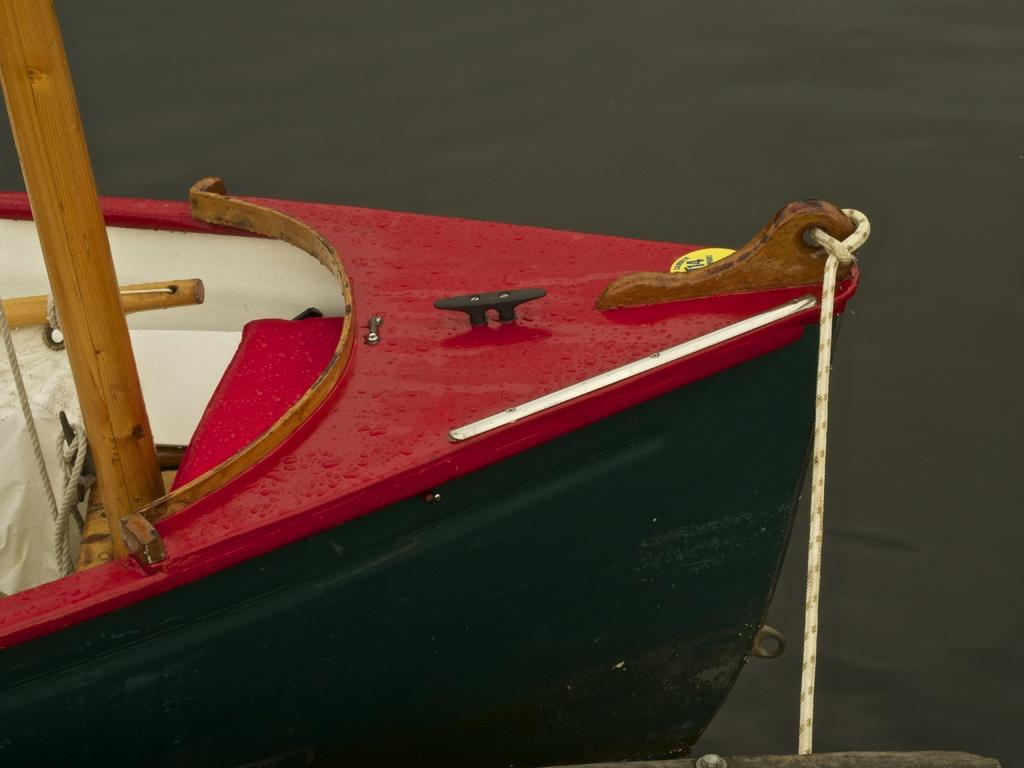What is the main subject of the image? The main subject of the image is a part of a boat. Where is the boat located? The boat is on a river. How many tents can be seen near the boat in the image? There are no tents present in the image; it only features a part of a boat on a river. What color is the toe of the person operating the boat in the image? There is no person or toe visible in the image; it only shows a part of a boat on a river. 